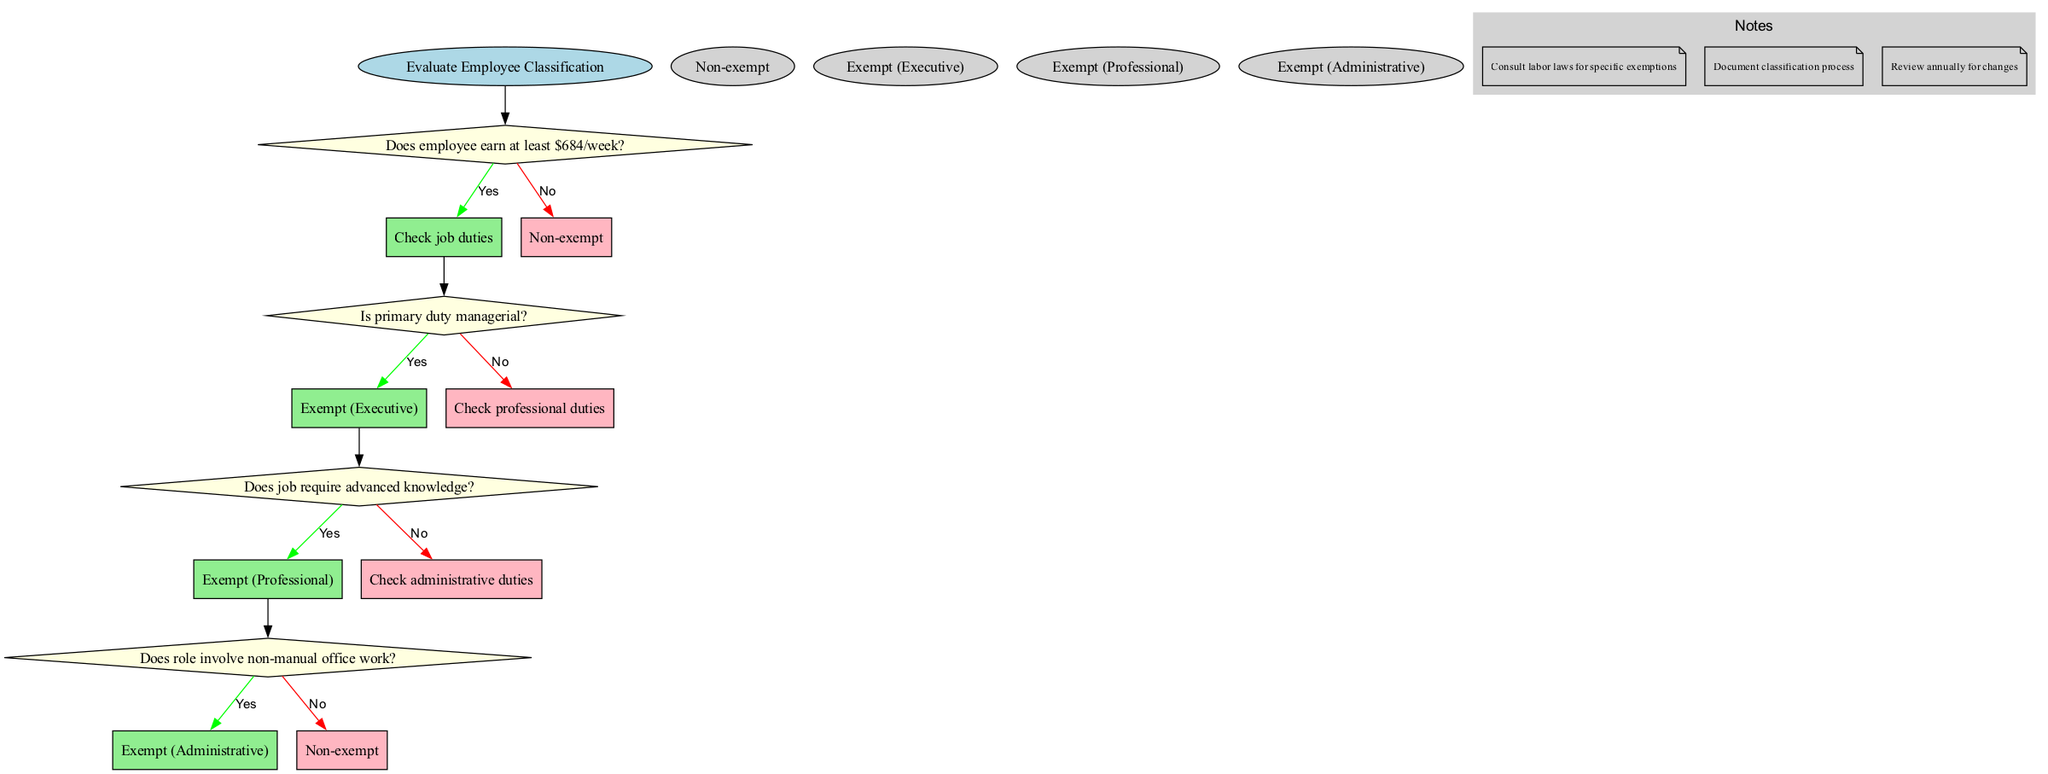What is the first question in the flowchart? The flowchart begins with the start node, which directs to the first decision node that asks, “Does employee earn at least $684/week?”
Answer: Does employee earn at least $684/week? How many total decisions are present in the diagram? The diagram presents a total of four decisions, each represented by a diamond-shaped node that asks a specific question related to employee classification.
Answer: Four What is the final classification if the answer to all questions is "no"? Following the flowchart, if the answers to all questions are "no," the path leads directly to the final classification at the end node labeled "Non-exempt."
Answer: Non-exempt What is the second decision question in the flowchart? The second decision node asks, “Is primary duty managerial?”, which follows after evaluating the employee's weekly earnings.
Answer: Is primary duty managerial? What classification does the diagram associate with advanced knowledge? The flowchart specifies that if the job requires advanced knowledge, the classification is “Exempt (Professional).”
Answer: Exempt (Professional) Which decision node leads to the classification of “Exempt (Administrative)”? The decision node labeled “Does role involve non-manual office work?” leads to the classification of “Exempt (Administrative)” if answered positively.
Answer: Does role involve non-manual office work? What do the notes at the end of the flowchart suggest? The notes provide guidance that includes consulting labor laws for specific exemptions, documenting the classification process, and reviewing annually for changes.
Answer: Consult labor laws for specific exemptions What color represents non-exempt classifications in the diagram? The color used for non-exempt classifications in the diagram is light pink, clearly distinguishing it from exempt classifications, which use light green for yes answers.
Answer: Light pink If an employee earns less than $684 per week, what classification will they receive? The flowchart indicates that if an employee earns less than $684 per week, they will be classified as “Non-exempt,” as specified immediately in the first decision node.
Answer: Non-exempt 